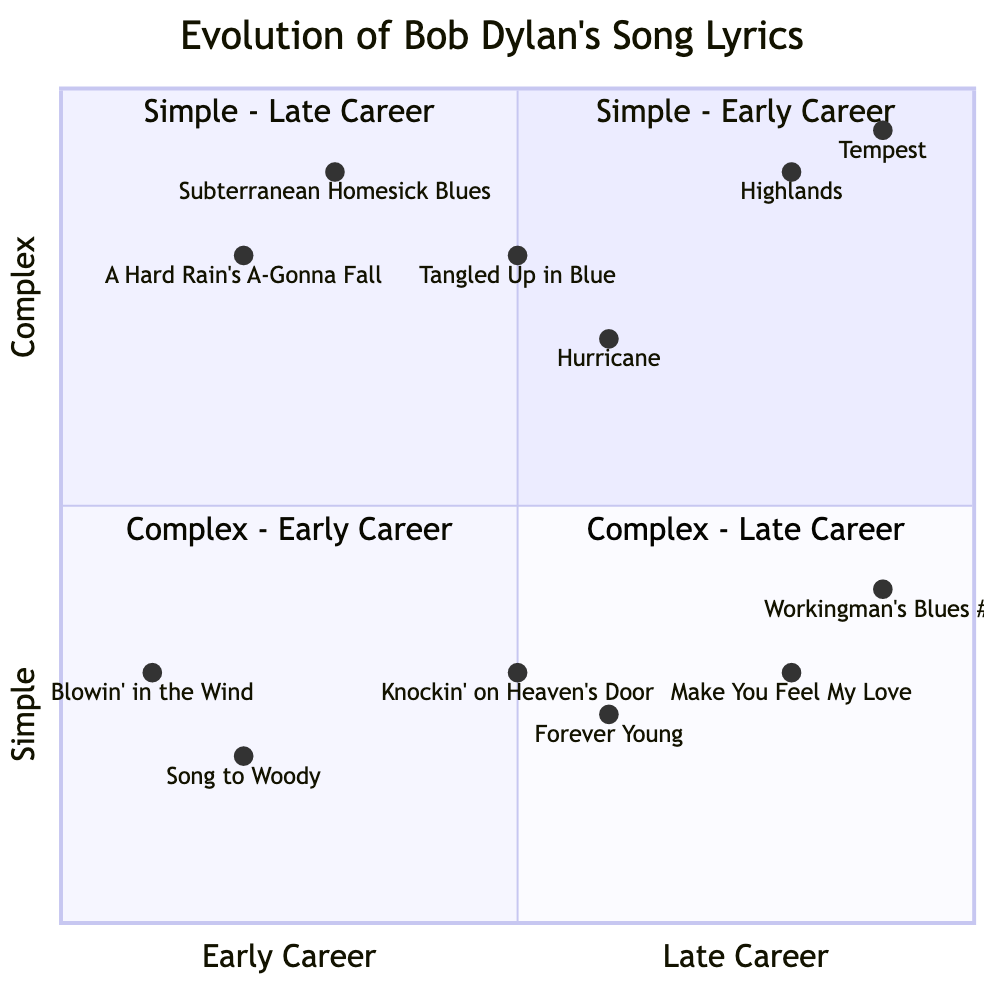What song represents the highest lyrical complexity in the early career quadrant? In the complex early career quadrant, the highest point corresponds to the song "Subterranean Homesick Blues," which is located at [0.3, 0.9].
Answer: Subterranean Homesick Blues How many songs are located in the simple mid-career quadrant? The simple mid-career quadrant contains two songs: "Knockin' on Heaven's Door" and "Forever Young."
Answer: 2 Which song from the complex late-career quadrant has the highest lyrical complexity? In the complex late-career quadrant, the song "Tempest" has the highest complexity, identified at the coordinates [0.9, 0.95].
Answer: Tempest What is the lyrical complexity value for "Tangled Up in Blue"? The position of "Tangled Up in Blue" indicates a lyrical complexity value of 0.8, as it is plotted at [0.5, 0.8].
Answer: 0.8 Which quadrant contains the song "Workingman's Blues #2"? "Workingman's Blues #2" is located in the simple late career quadrant, specifically represented by its coordinates [0.9, 0.4].
Answer: Simple - Late Career What is the relationship between early career songs and their lyrical complexity? Analyzing the early career quadrant, the songs generally exhibit a movement from simple ("Blowin' in the Wind") to complex ("A Hard Rain's A-Gonna Fall"), indicating an increase in lyrical complexity as the career progresses.
Answer: Increase in complexity How many total quadrants are present in the chart? The chart is divided into four quadrants: simple early career, simple mid career, complex early career, and complex late career. Thus, it contains a total of four quadrants.
Answer: 4 What is the lyrical complexity of "Make You Feel My Love"? The song "Make You Feel My Love" has a lyrical complexity value of 0.3, indicated by its position at [0.8, 0.3].
Answer: 0.3 Which early career song has the simplest lyrics? Among the early career songs, "Song to Woody" represents the simplest lyrics, plotted at [0.2, 0.2].
Answer: Song to Woody 